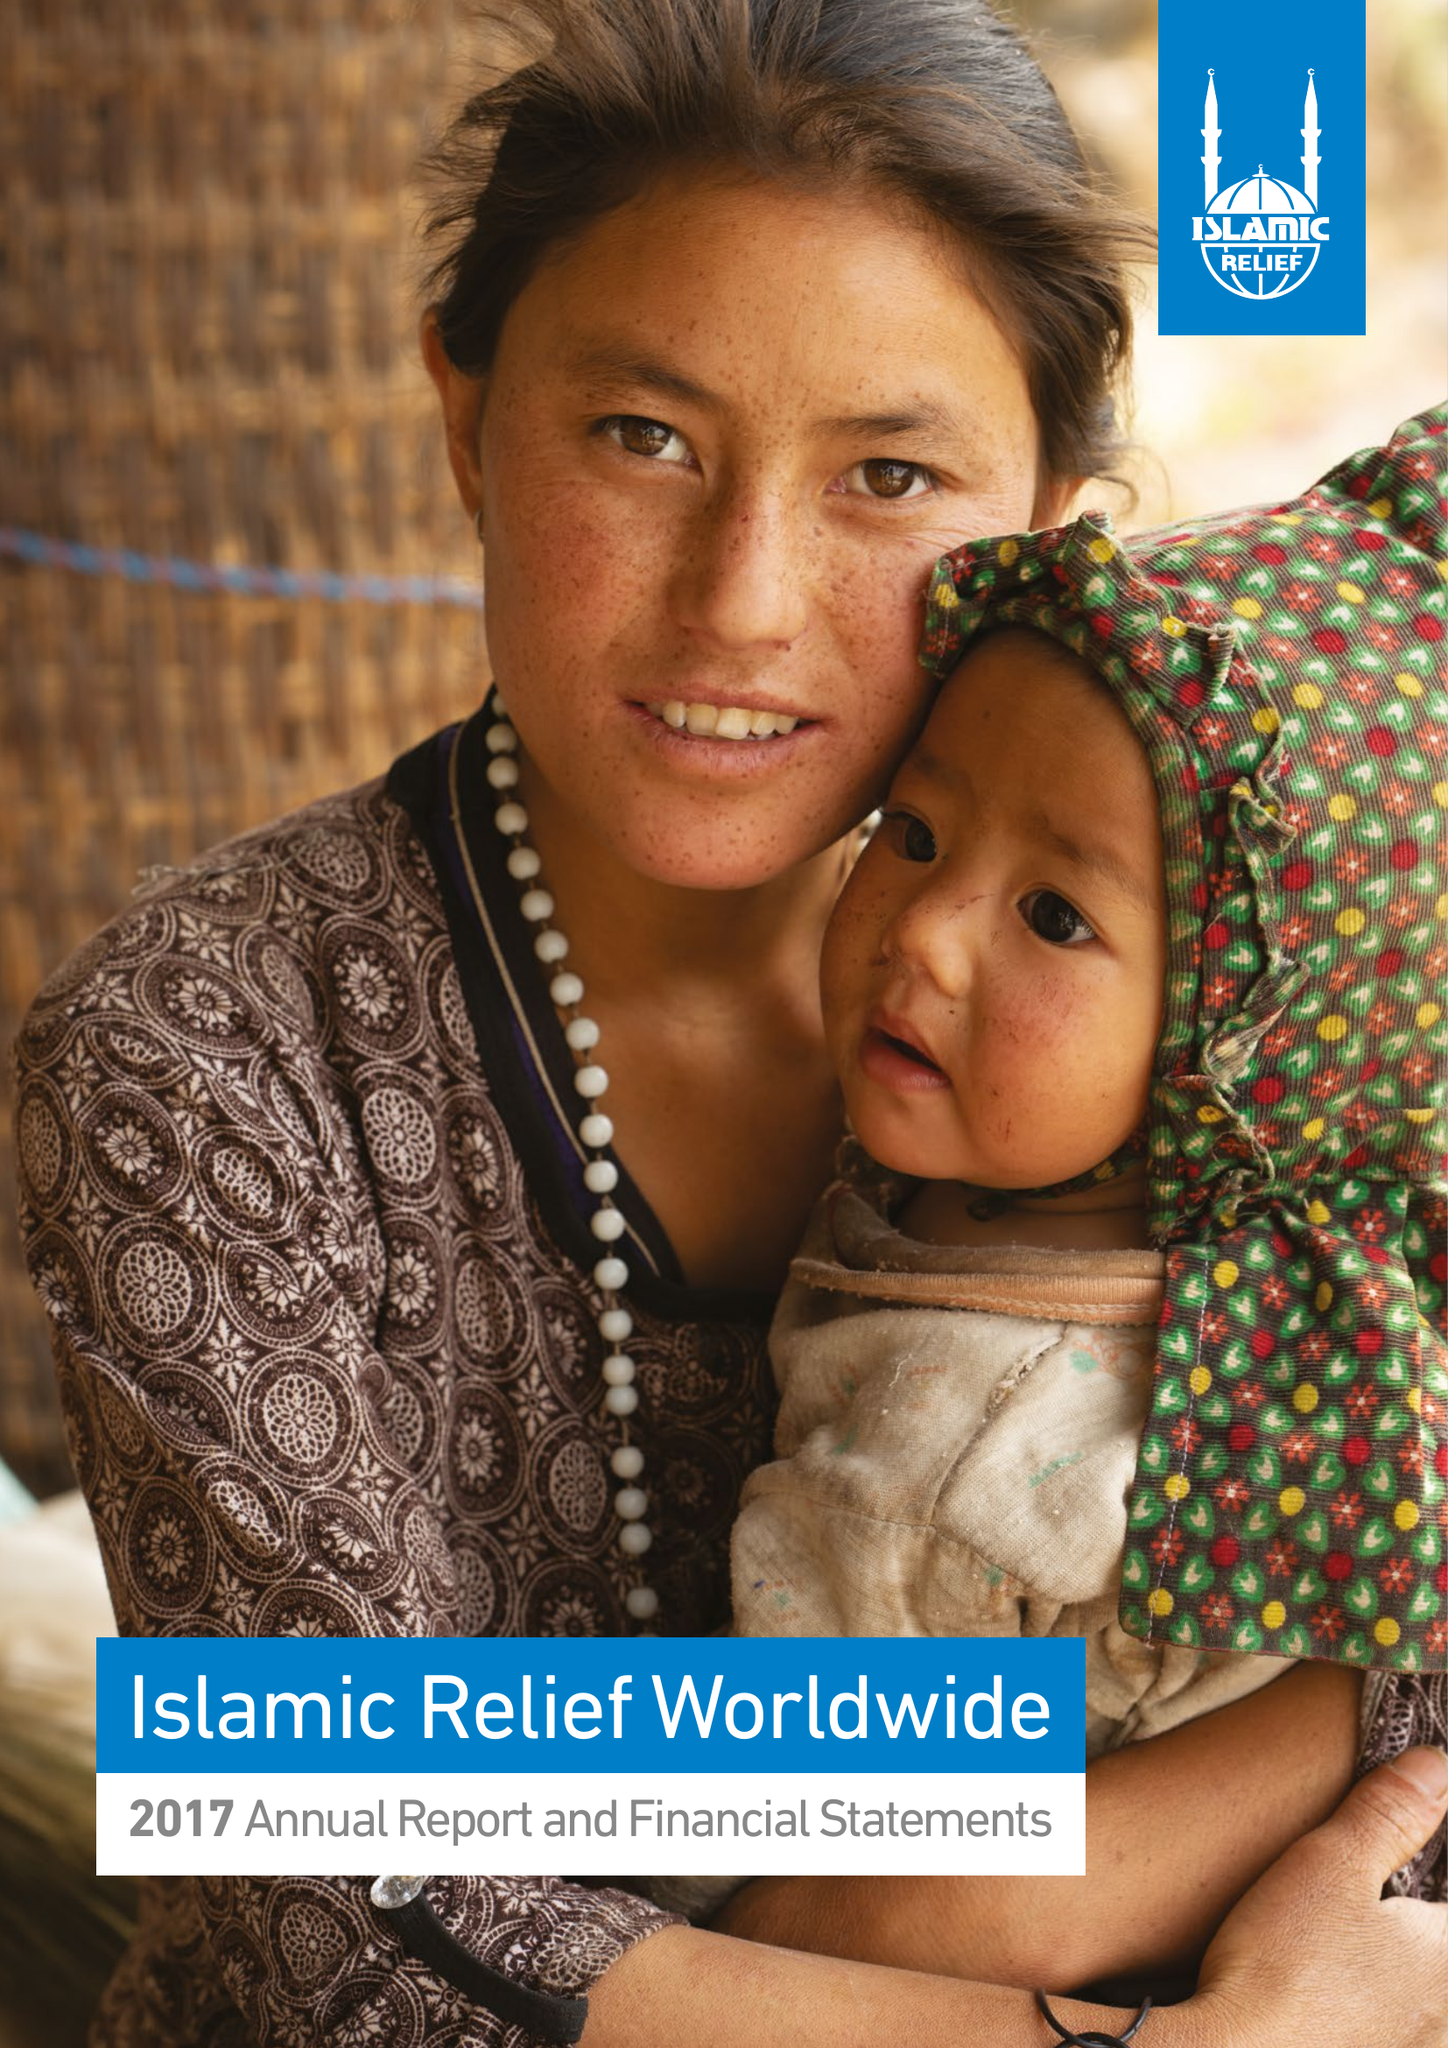What is the value for the charity_name?
Answer the question using a single word or phrase. Islamic Relief Worldwide 